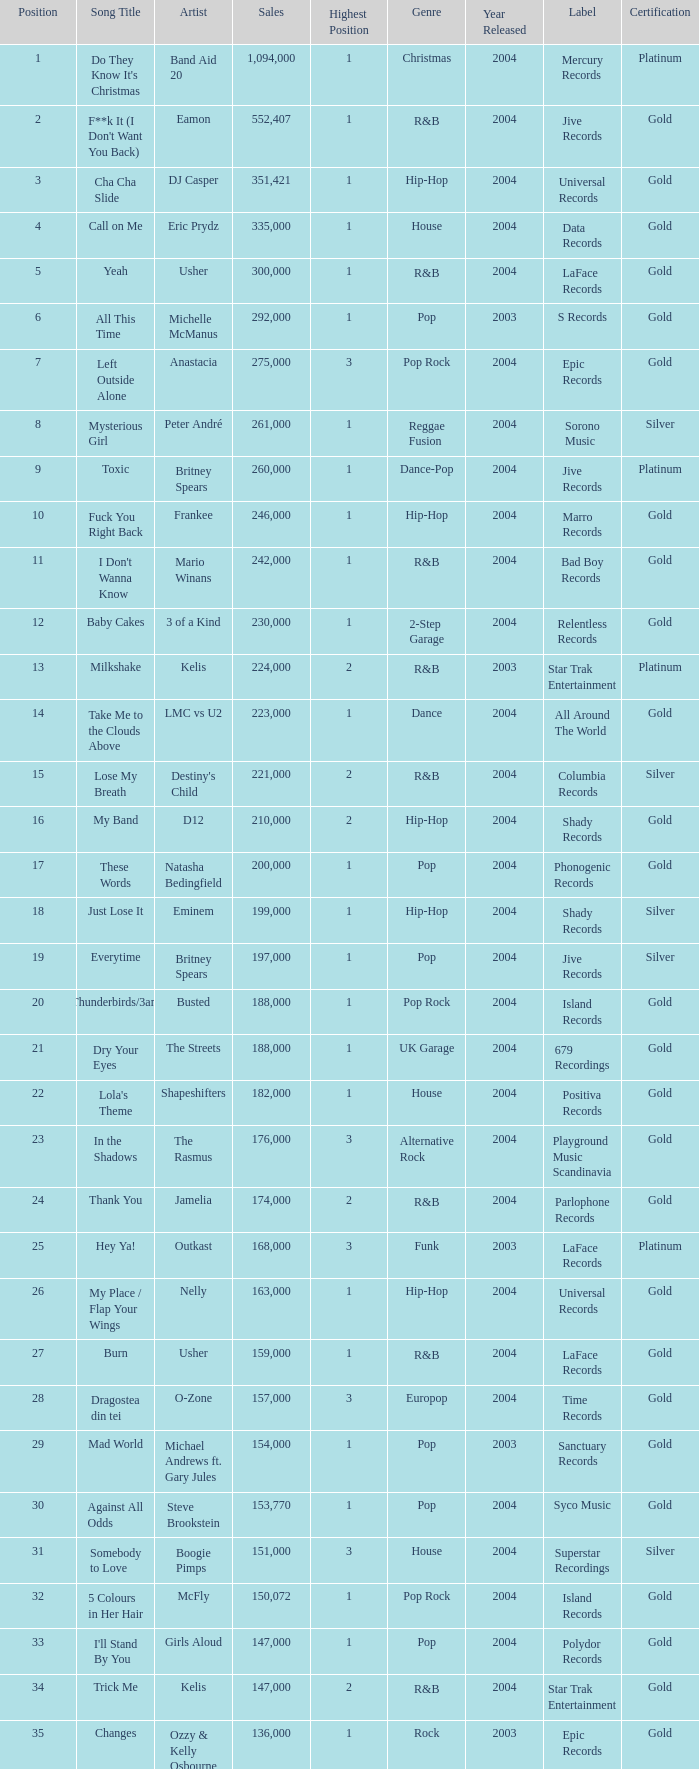What is the most sales by a song with a position higher than 3? None. 